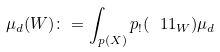Convert formula to latex. <formula><loc_0><loc_0><loc_500><loc_500>\mu _ { d } ( W ) \colon = \int _ { p ( X ) } p _ { ! } ( \ 1 1 _ { W } ) \mu _ { d }</formula> 